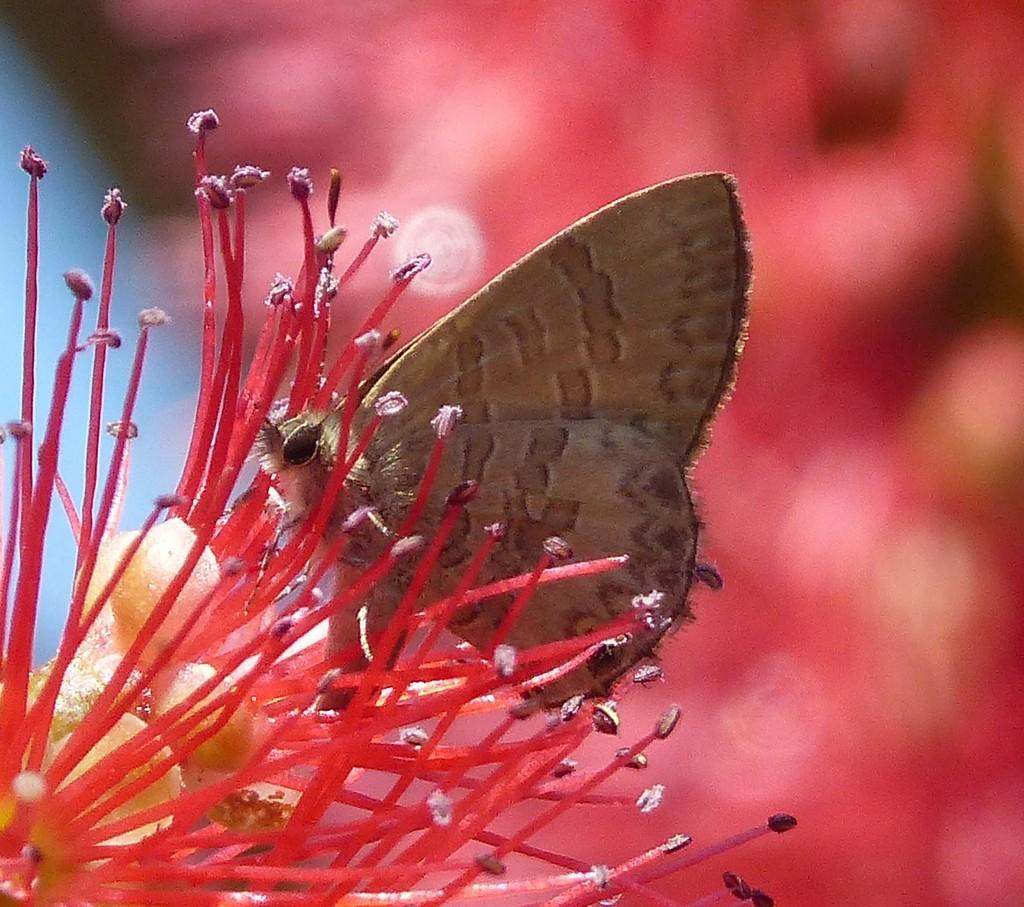What is the main subject of the image? There is an insect in the image. Where is the insect located? The insect is on a flower. Can you describe the background of the image? The background of the image is blurry. What type of vacation is the insect planning to take in the image? There is no indication in the image that the insect is planning a vacation, as insects do not plan vacations. 